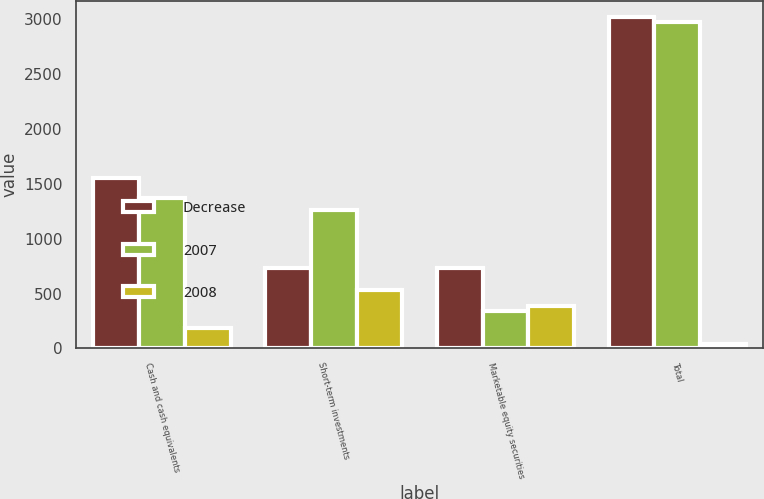Convert chart to OTSL. <chart><loc_0><loc_0><loc_500><loc_500><stacked_bar_chart><ecel><fcel>Cash and cash equivalents<fcel>Short-term investments<fcel>Marketable equity securities<fcel>Total<nl><fcel>Decrease<fcel>1553<fcel>734<fcel>729<fcel>3016<nl><fcel>2007<fcel>1371<fcel>1264<fcel>341<fcel>2976<nl><fcel>2008<fcel>182<fcel>530<fcel>388<fcel>40<nl></chart> 